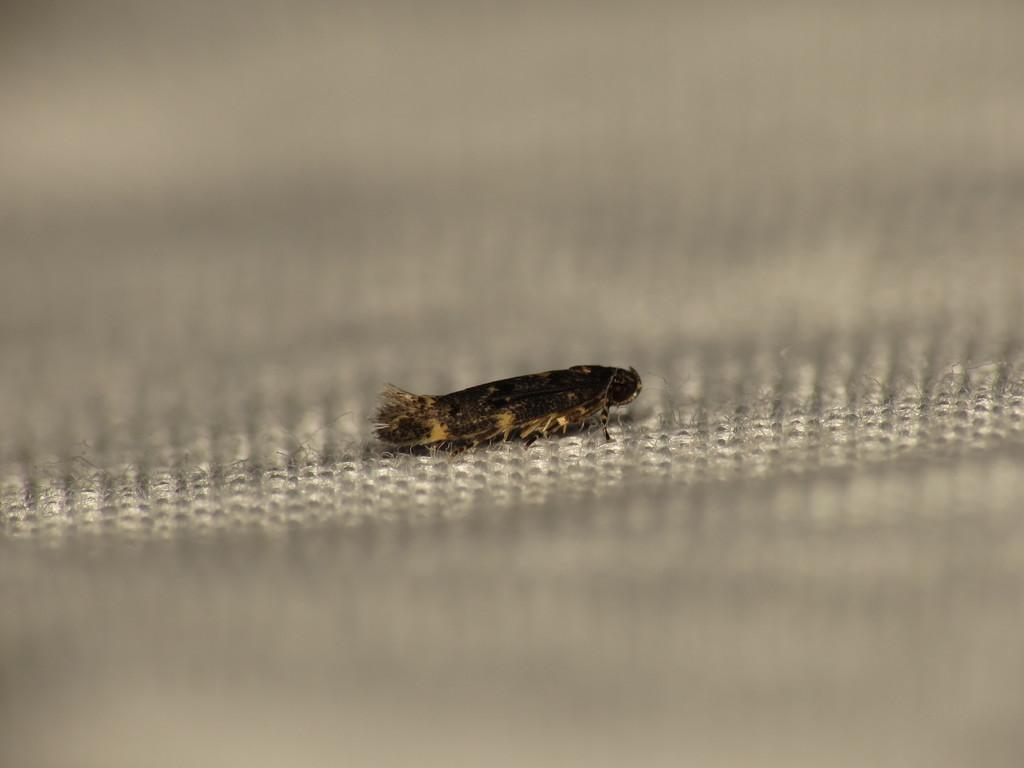How would you summarize this image in a sentence or two? In this image there is an insect on the surface. 